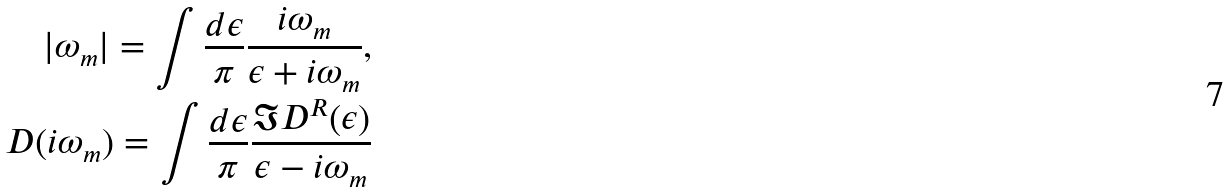Convert formula to latex. <formula><loc_0><loc_0><loc_500><loc_500>| \omega _ { m } | = \int \frac { d \epsilon } { \pi } \frac { i \omega _ { m } } { \epsilon + i \omega _ { m } } , \\ D ( i \omega _ { m } ) = \int \frac { d \epsilon } { \pi } \frac { \Im D ^ { R } ( \epsilon ) } { \epsilon - i \omega _ { m } }</formula> 